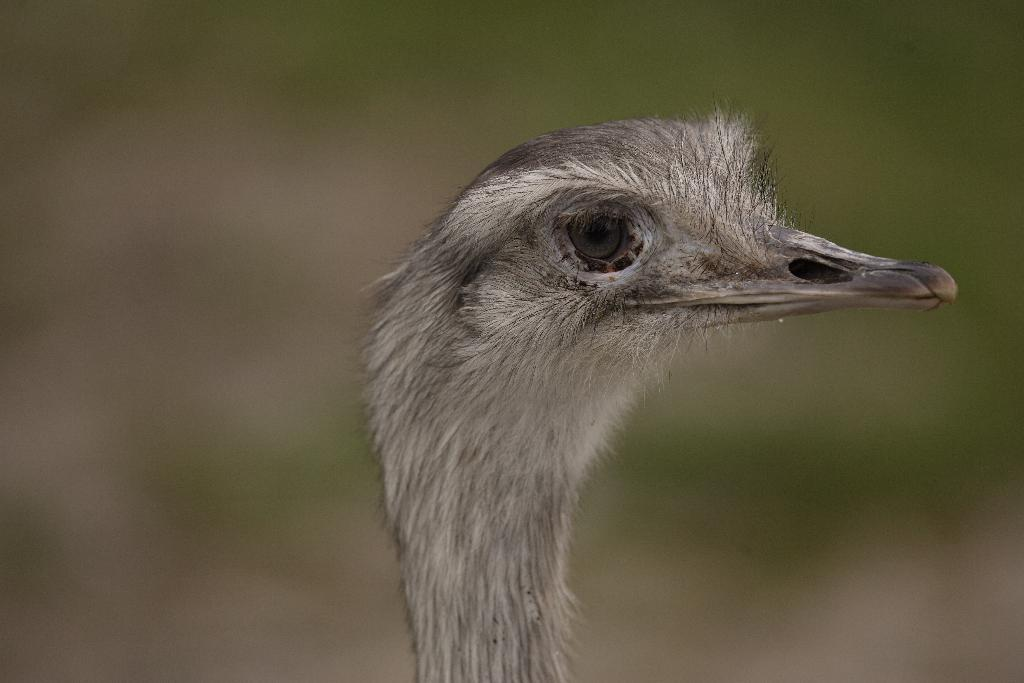What is the main subject of the image? The main subject of the image is a bird's head. In which direction is the bird's head facing? The bird's head is facing towards the right. What type of gold apparel is the bird wearing in the image? There is no gold apparel present in the image, as it only features a bird's head. 